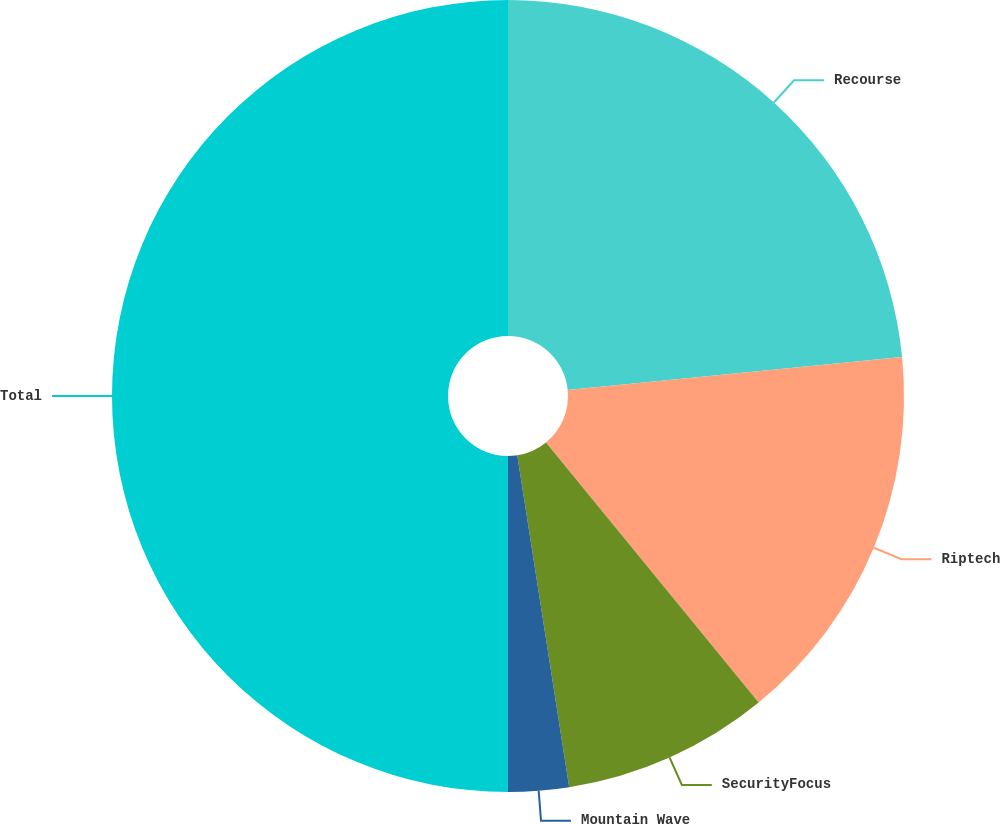Convert chart to OTSL. <chart><loc_0><loc_0><loc_500><loc_500><pie_chart><fcel>Recourse<fcel>Riptech<fcel>SecurityFocus<fcel>Mountain Wave<fcel>Total<nl><fcel>23.43%<fcel>15.66%<fcel>8.44%<fcel>2.47%<fcel>50.0%<nl></chart> 